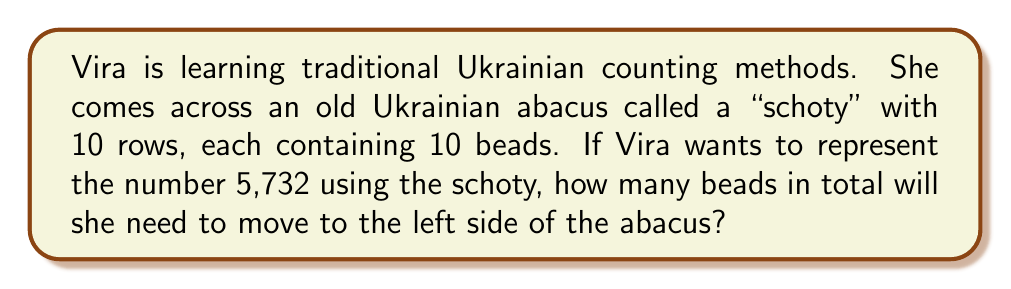Can you answer this question? To solve this problem using traditional Ukrainian counting methods with a schoty, we need to understand how it works:

1. The schoty has 10 rows, each representing a place value (ones, tens, hundreds, etc.).
2. Each row has 10 beads, and beads moved to the left side represent the count for that place value.

For the number 5,732:

1. In the ones place (bottom row): Move 2 beads to the left.
2. In the tens place (second row from bottom): Move 3 beads to the left.
3. In the hundreds place (third row from bottom): Move 7 beads to the left.
4. In the thousands place (fourth row from bottom): Move 5 beads to the left.

To calculate the total number of beads moved:

$$ \text{Total beads} = 2 + 3 + 7 + 5 = 17 $$

Therefore, Vira will need to move a total of 17 beads to the left side of the schoty to represent the number 5,732.
Answer: 17 beads 